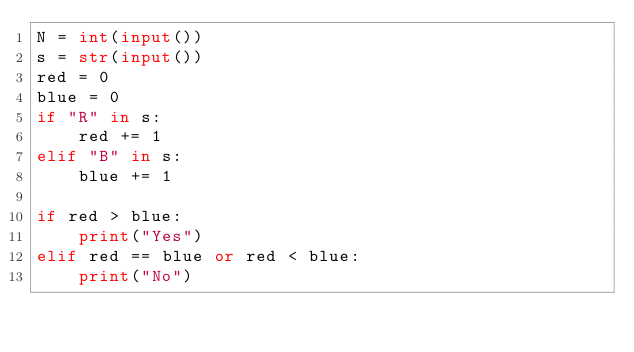<code> <loc_0><loc_0><loc_500><loc_500><_Python_>N = int(input())
s = str(input())
red = 0
blue = 0
if "R" in s:
    red += 1
elif "B" in s:
    blue += 1

if red > blue:
    print("Yes")
elif red == blue or red < blue:
    print("No")
    </code> 